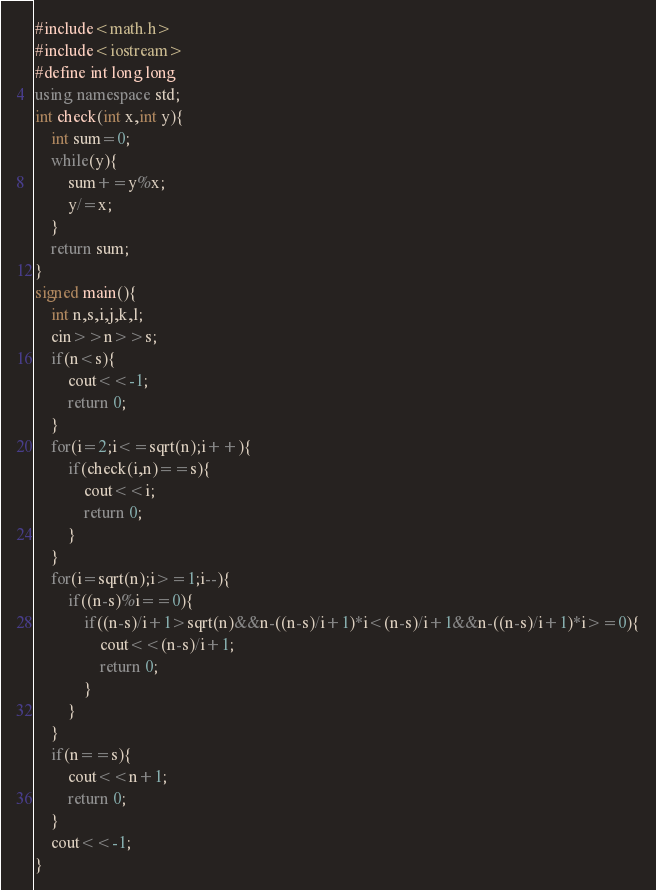<code> <loc_0><loc_0><loc_500><loc_500><_C++_>#include<math.h>
#include<iostream>
#define int long long
using namespace std;
int check(int x,int y){
	int sum=0;
	while(y){
		sum+=y%x;
		y/=x;
	}
	return sum;
}
signed main(){
	int n,s,i,j,k,l;
	cin>>n>>s;
	if(n<s){
		cout<<-1;
		return 0;
	}
	for(i=2;i<=sqrt(n);i++){
		if(check(i,n)==s){
			cout<<i;
			return 0;
		}
	}
	for(i=sqrt(n);i>=1;i--){
		if((n-s)%i==0){
			if((n-s)/i+1>sqrt(n)&&n-((n-s)/i+1)*i<(n-s)/i+1&&n-((n-s)/i+1)*i>=0){
				cout<<(n-s)/i+1;
				return 0;
			}
		}
	}
	if(n==s){
		cout<<n+1;
		return 0;
	}
	cout<<-1;
}</code> 